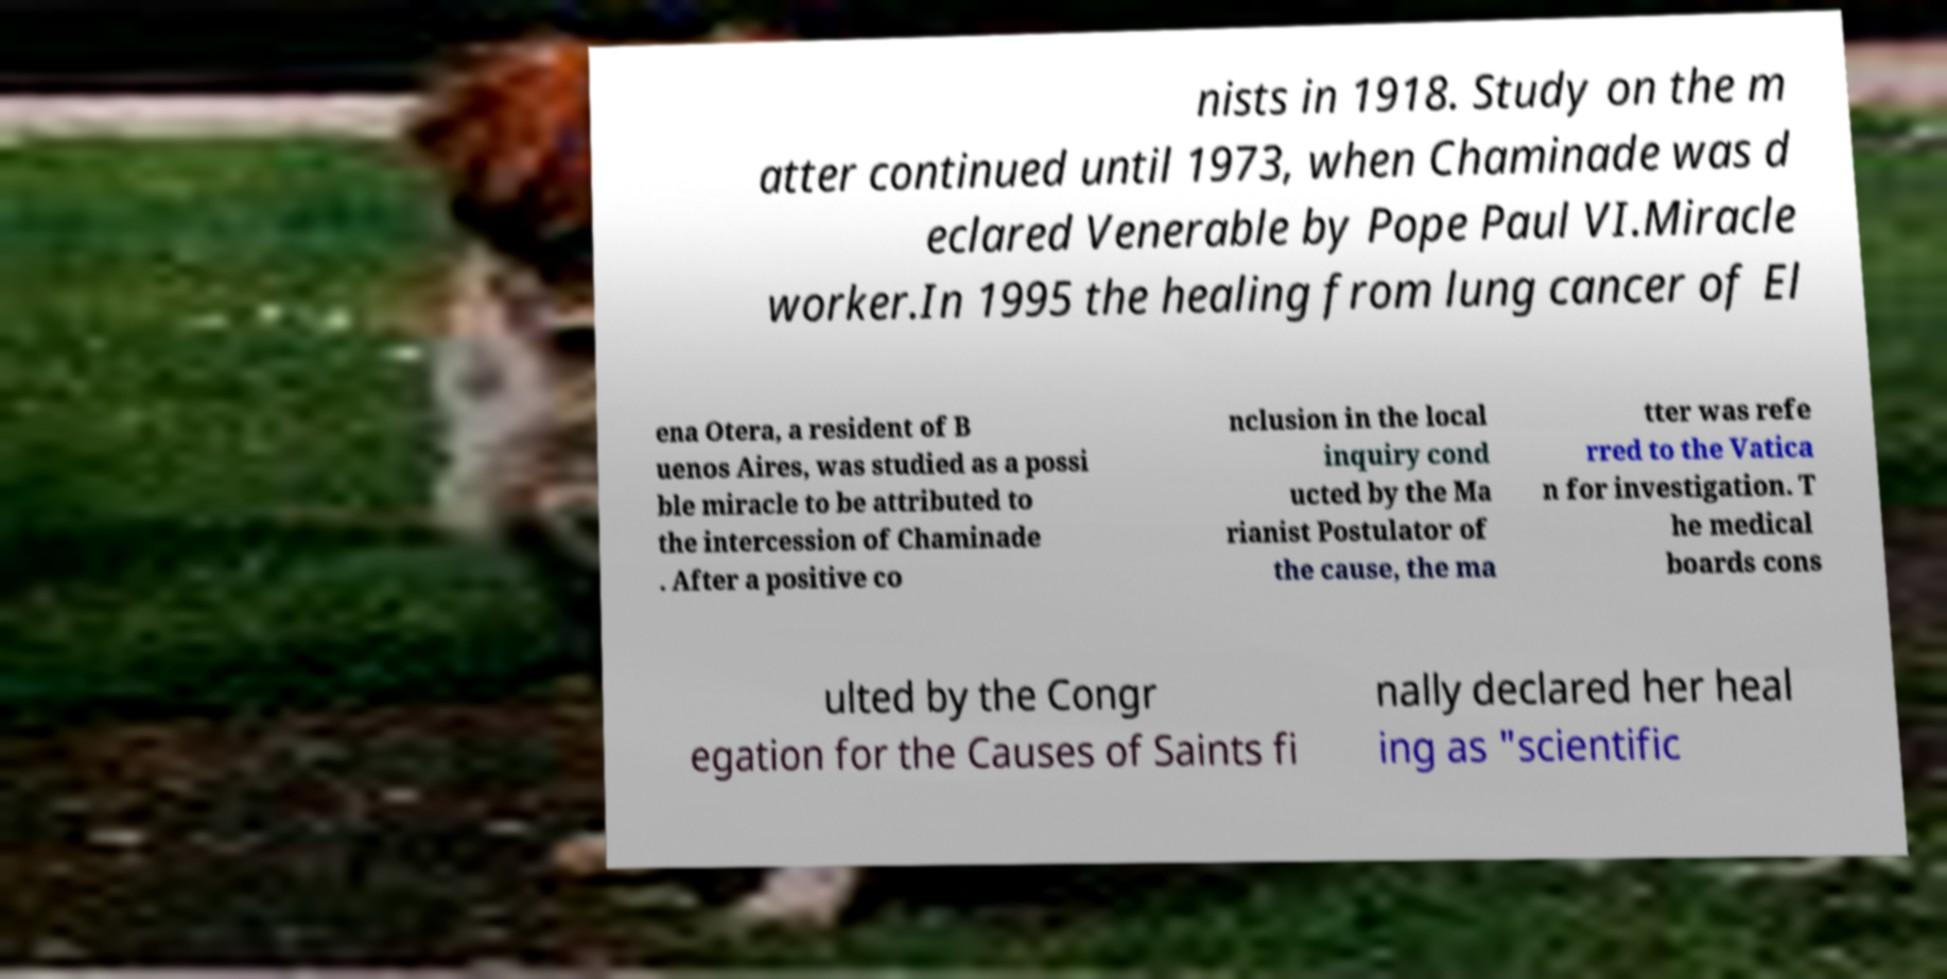Please read and relay the text visible in this image. What does it say? nists in 1918. Study on the m atter continued until 1973, when Chaminade was d eclared Venerable by Pope Paul VI.Miracle worker.In 1995 the healing from lung cancer of El ena Otera, a resident of B uenos Aires, was studied as a possi ble miracle to be attributed to the intercession of Chaminade . After a positive co nclusion in the local inquiry cond ucted by the Ma rianist Postulator of the cause, the ma tter was refe rred to the Vatica n for investigation. T he medical boards cons ulted by the Congr egation for the Causes of Saints fi nally declared her heal ing as "scientific 